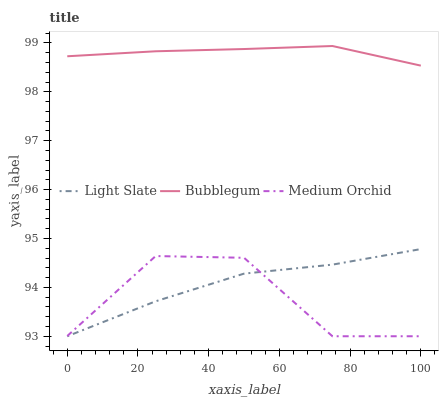Does Medium Orchid have the minimum area under the curve?
Answer yes or no. Yes. Does Bubblegum have the maximum area under the curve?
Answer yes or no. Yes. Does Bubblegum have the minimum area under the curve?
Answer yes or no. No. Does Medium Orchid have the maximum area under the curve?
Answer yes or no. No. Is Bubblegum the smoothest?
Answer yes or no. Yes. Is Medium Orchid the roughest?
Answer yes or no. Yes. Is Medium Orchid the smoothest?
Answer yes or no. No. Is Bubblegum the roughest?
Answer yes or no. No. Does Light Slate have the lowest value?
Answer yes or no. Yes. Does Bubblegum have the lowest value?
Answer yes or no. No. Does Bubblegum have the highest value?
Answer yes or no. Yes. Does Medium Orchid have the highest value?
Answer yes or no. No. Is Light Slate less than Bubblegum?
Answer yes or no. Yes. Is Bubblegum greater than Light Slate?
Answer yes or no. Yes. Does Light Slate intersect Medium Orchid?
Answer yes or no. Yes. Is Light Slate less than Medium Orchid?
Answer yes or no. No. Is Light Slate greater than Medium Orchid?
Answer yes or no. No. Does Light Slate intersect Bubblegum?
Answer yes or no. No. 